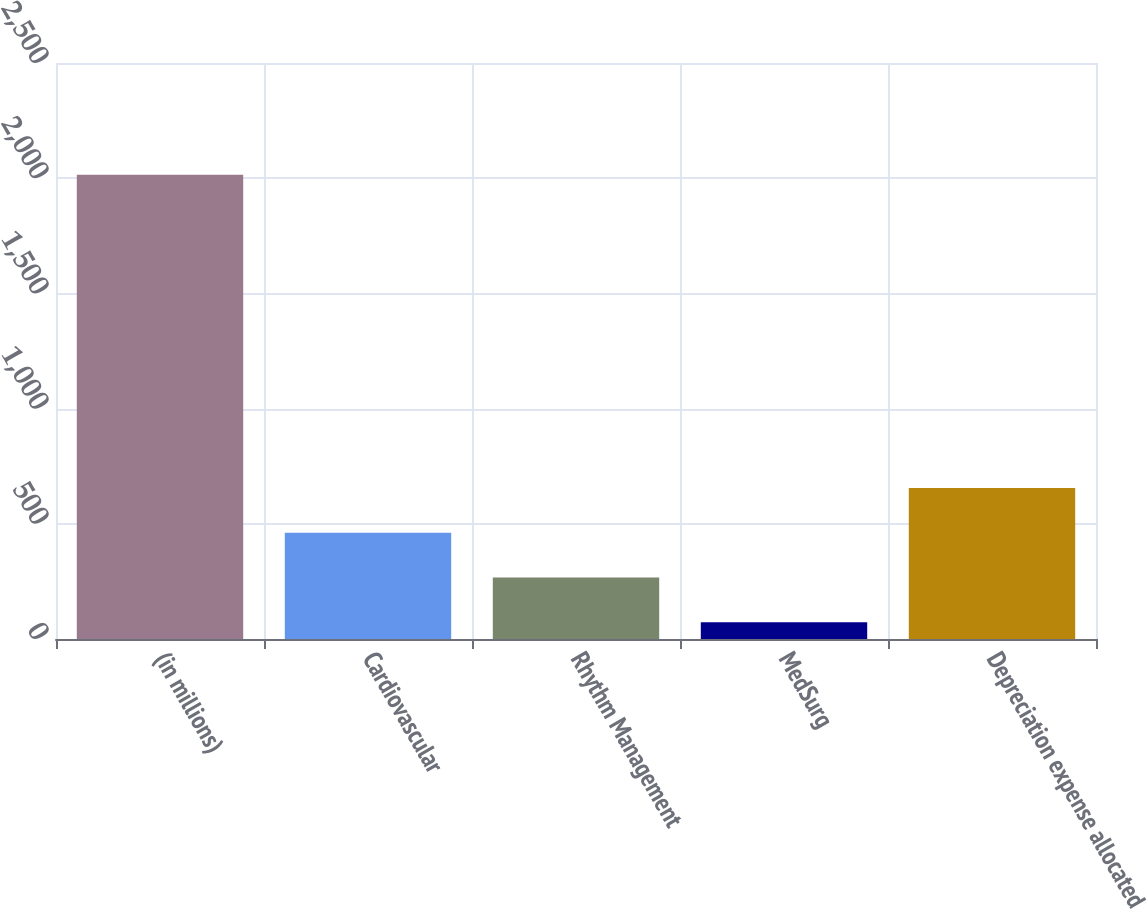Convert chart to OTSL. <chart><loc_0><loc_0><loc_500><loc_500><bar_chart><fcel>(in millions)<fcel>Cardiovascular<fcel>Rhythm Management<fcel>MedSurg<fcel>Depreciation expense allocated<nl><fcel>2015<fcel>461.4<fcel>267.2<fcel>73<fcel>655.6<nl></chart> 